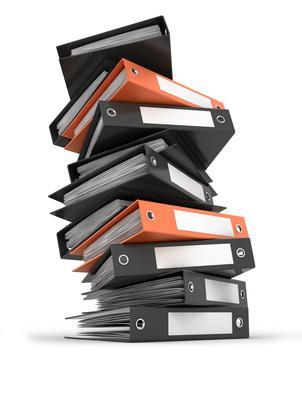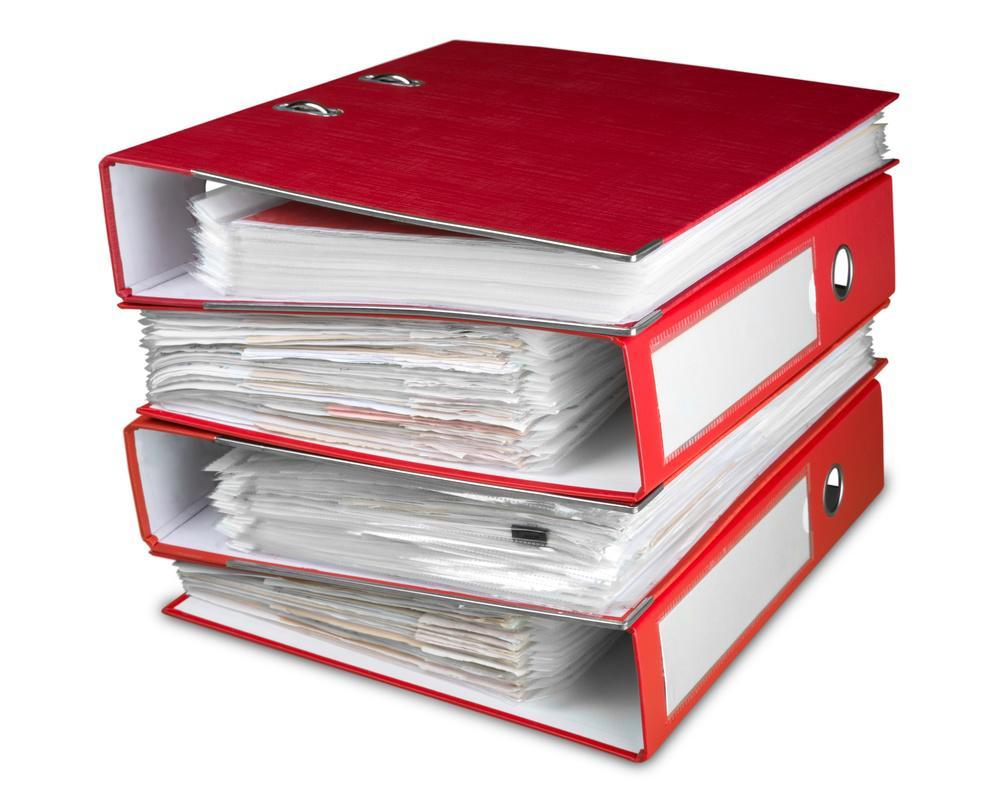The first image is the image on the left, the second image is the image on the right. For the images shown, is this caption "Multiple black and orange binders are stacked on top of one another" true? Answer yes or no. Yes. The first image is the image on the left, the second image is the image on the right. Analyze the images presented: Is the assertion "There are stacks of binders with orange mixed with black" valid? Answer yes or no. Yes. 